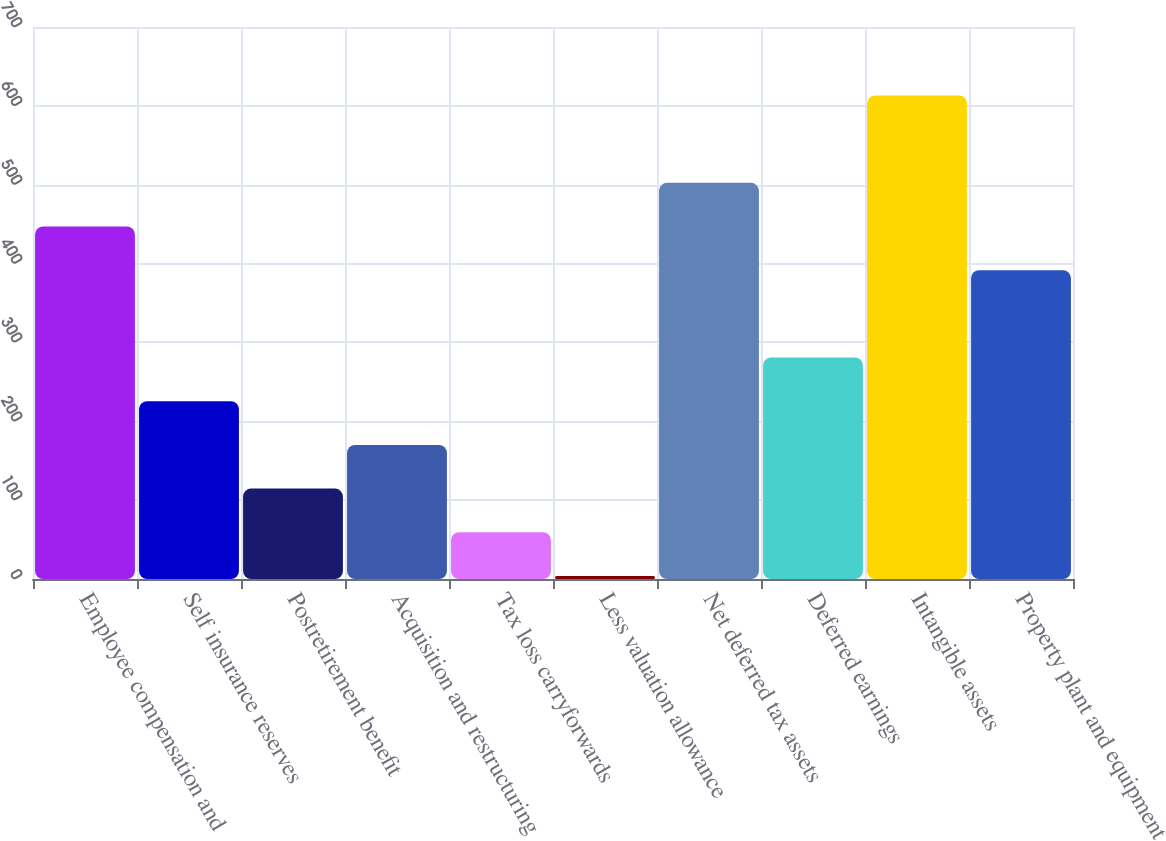Convert chart to OTSL. <chart><loc_0><loc_0><loc_500><loc_500><bar_chart><fcel>Employee compensation and<fcel>Self insurance reserves<fcel>Postretirement benefit<fcel>Acquisition and restructuring<fcel>Tax loss carryforwards<fcel>Less valuation allowance<fcel>Net deferred tax assets<fcel>Deferred earnings<fcel>Intangible assets<fcel>Property plant and equipment<nl><fcel>447.02<fcel>225.46<fcel>114.68<fcel>170.07<fcel>59.29<fcel>3.9<fcel>502.41<fcel>280.85<fcel>613.19<fcel>391.63<nl></chart> 